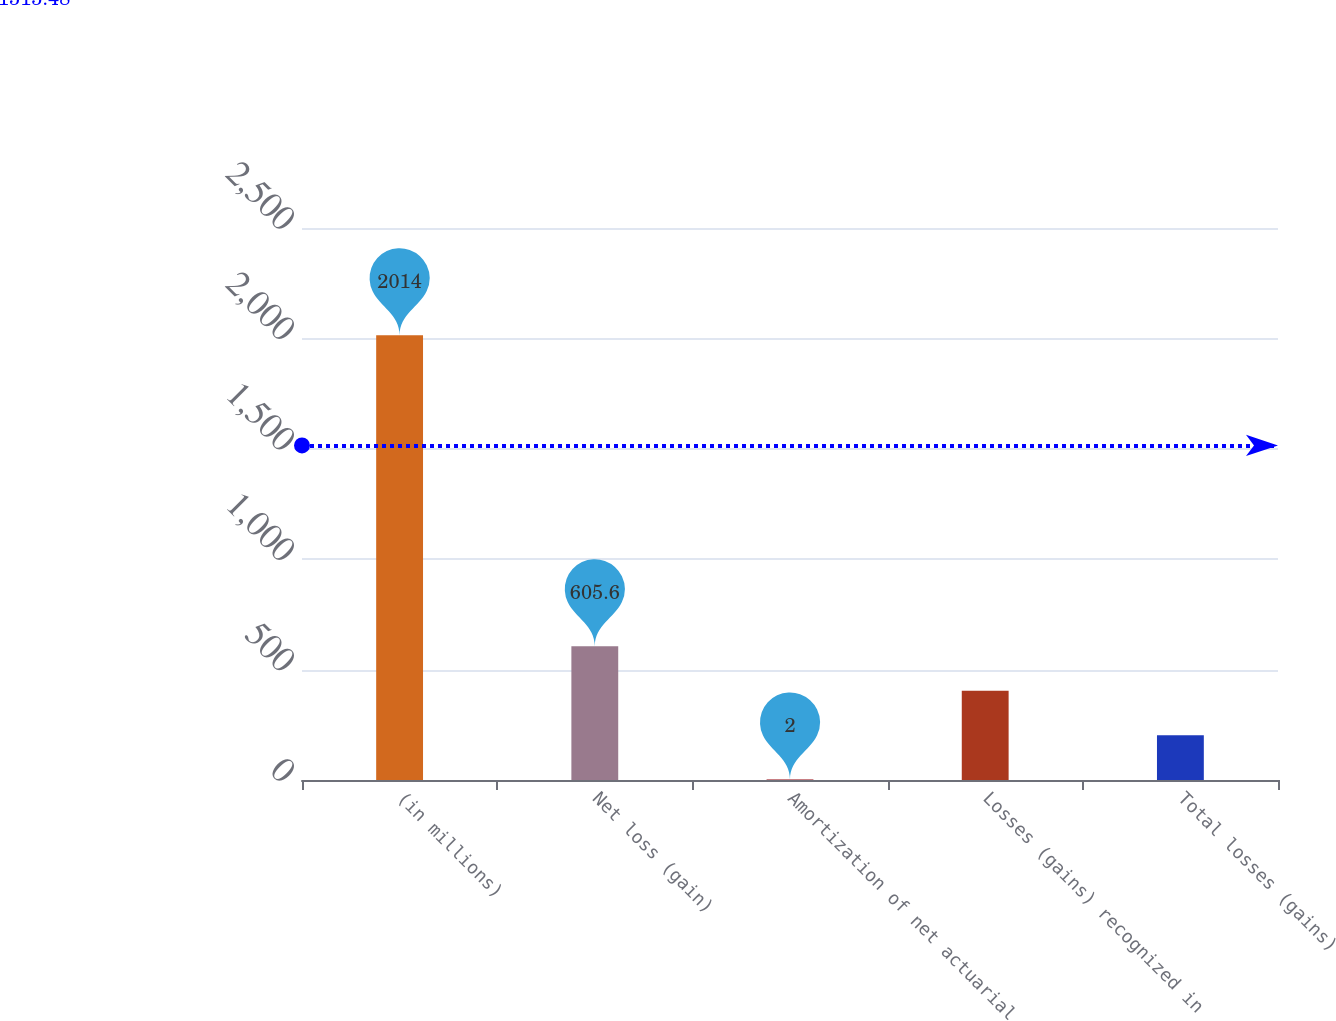<chart> <loc_0><loc_0><loc_500><loc_500><bar_chart><fcel>(in millions)<fcel>Net loss (gain)<fcel>Amortization of net actuarial<fcel>Losses (gains) recognized in<fcel>Total losses (gains)<nl><fcel>2014<fcel>605.6<fcel>2<fcel>404.4<fcel>203.2<nl></chart> 